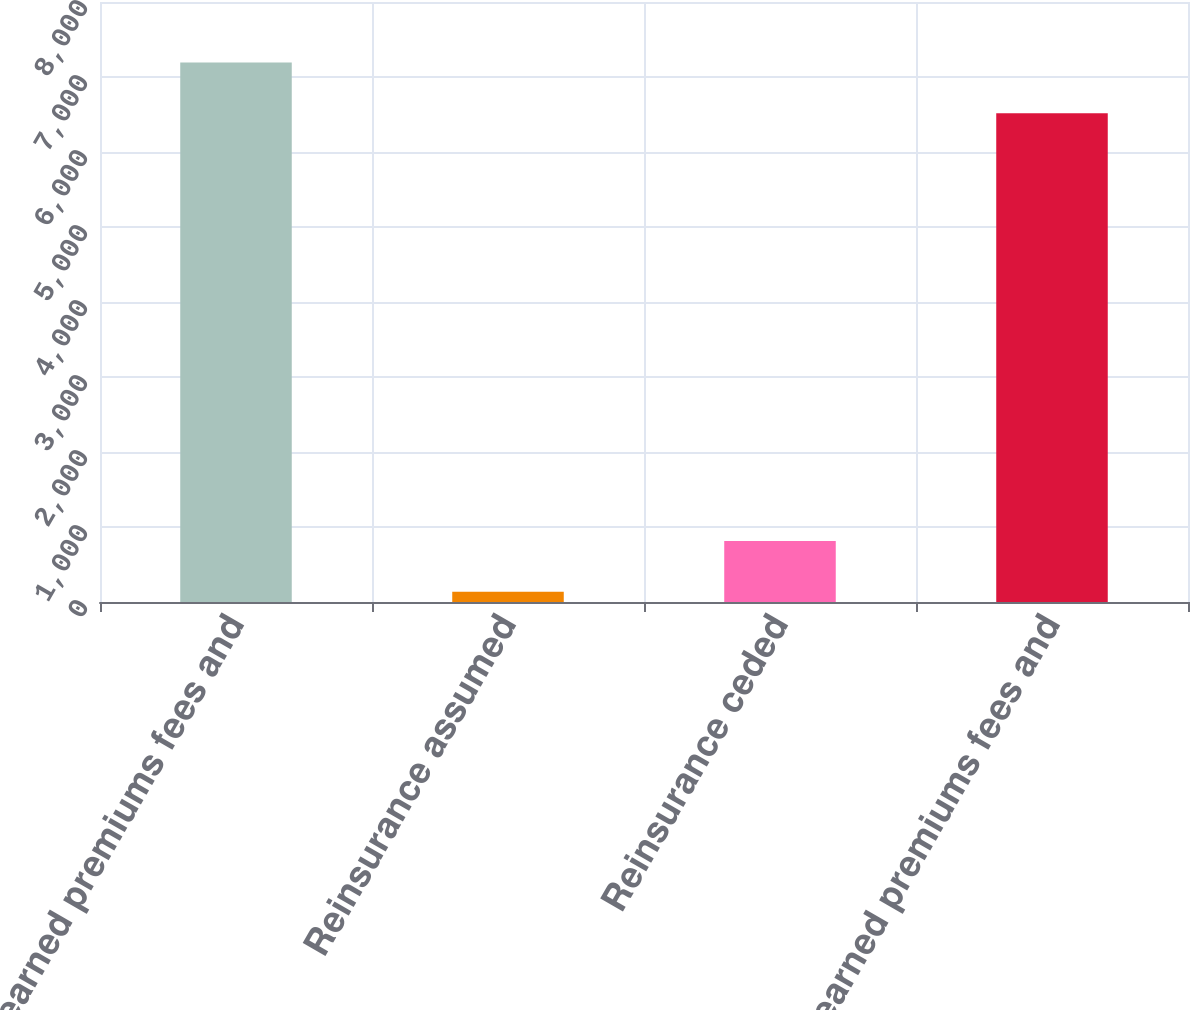Convert chart to OTSL. <chart><loc_0><loc_0><loc_500><loc_500><bar_chart><fcel>Gross earned premiums fees and<fcel>Reinsurance assumed<fcel>Reinsurance ceded<fcel>Net earned premiums fees and<nl><fcel>7194.8<fcel>137<fcel>813.8<fcel>6518<nl></chart> 